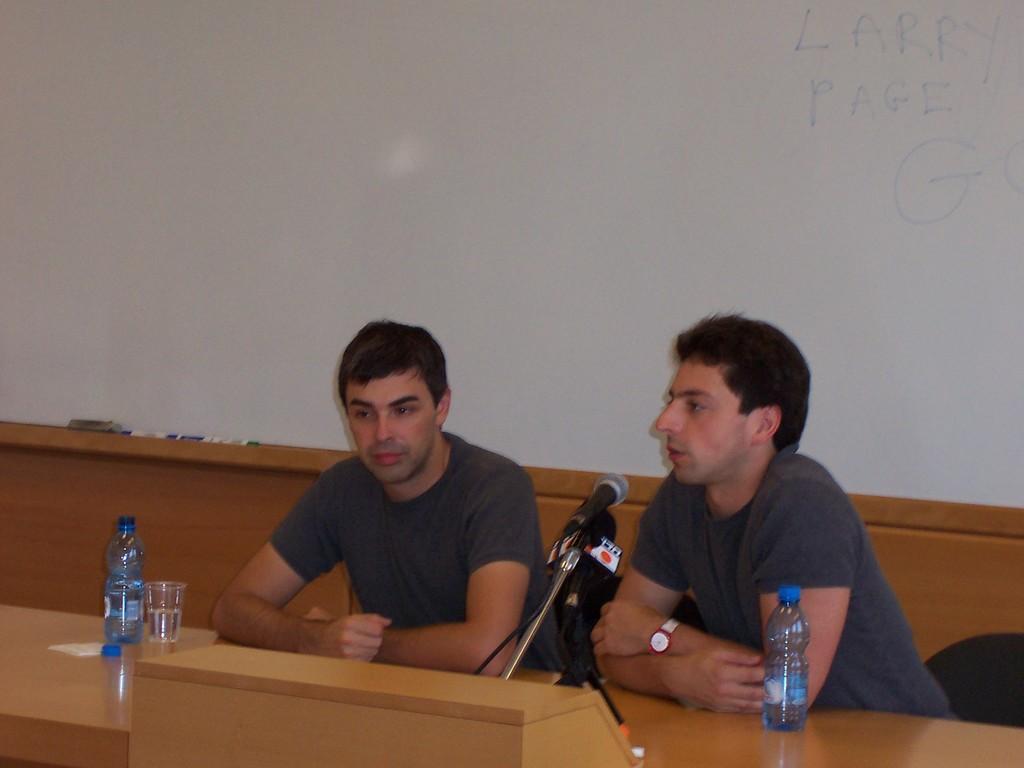In one or two sentences, can you explain what this image depicts? In this picture there are two men who are sitting on a bench. There is a glass, bottle, paper, mic on the table. There are markers and a grey object in the background. 